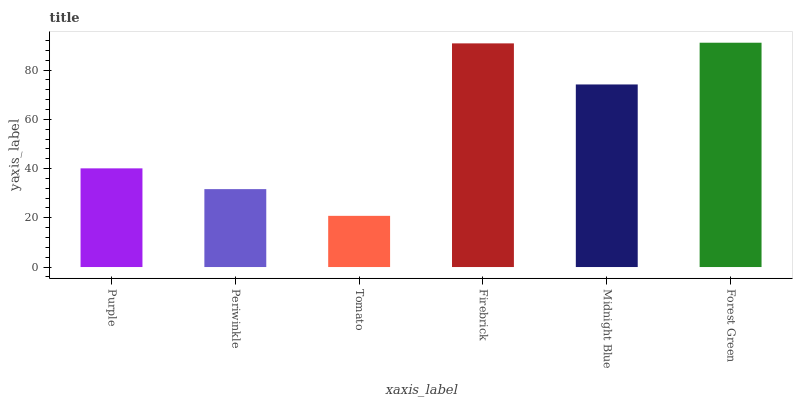Is Periwinkle the minimum?
Answer yes or no. No. Is Periwinkle the maximum?
Answer yes or no. No. Is Purple greater than Periwinkle?
Answer yes or no. Yes. Is Periwinkle less than Purple?
Answer yes or no. Yes. Is Periwinkle greater than Purple?
Answer yes or no. No. Is Purple less than Periwinkle?
Answer yes or no. No. Is Midnight Blue the high median?
Answer yes or no. Yes. Is Purple the low median?
Answer yes or no. Yes. Is Firebrick the high median?
Answer yes or no. No. Is Tomato the low median?
Answer yes or no. No. 